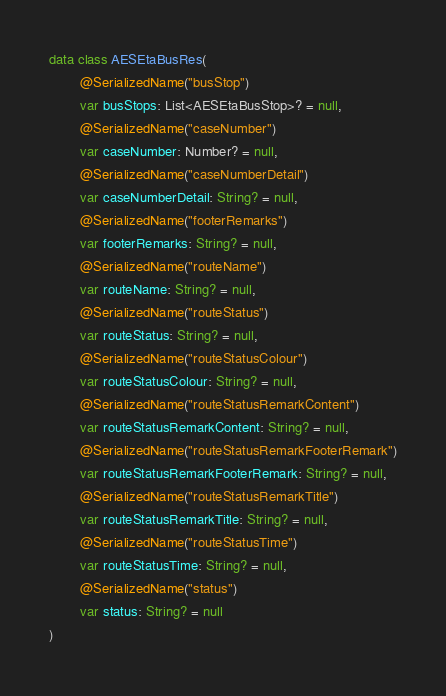Convert code to text. <code><loc_0><loc_0><loc_500><loc_500><_Kotlin_>data class AESEtaBusRes(
        @SerializedName("busStop")
        var busStops: List<AESEtaBusStop>? = null,
        @SerializedName("caseNumber")
        var caseNumber: Number? = null,
        @SerializedName("caseNumberDetail")
        var caseNumberDetail: String? = null,
        @SerializedName("footerRemarks")
        var footerRemarks: String? = null,
        @SerializedName("routeName")
        var routeName: String? = null,
        @SerializedName("routeStatus")
        var routeStatus: String? = null,
        @SerializedName("routeStatusColour")
        var routeStatusColour: String? = null,
        @SerializedName("routeStatusRemarkContent")
        var routeStatusRemarkContent: String? = null,
        @SerializedName("routeStatusRemarkFooterRemark")
        var routeStatusRemarkFooterRemark: String? = null,
        @SerializedName("routeStatusRemarkTitle")
        var routeStatusRemarkTitle: String? = null,
        @SerializedName("routeStatusTime")
        var routeStatusTime: String? = null,
        @SerializedName("status")
        var status: String? = null
)</code> 